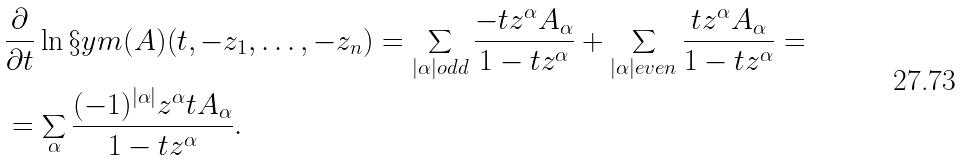<formula> <loc_0><loc_0><loc_500><loc_500>& \frac { \partial } { \partial t } \ln \S y m ( A ) ( t , - z _ { 1 } , \dots , - z _ { n } ) = \sum _ { | \alpha | o d d } \frac { - t z ^ { \alpha } A _ { \alpha } } { 1 - t z ^ { \alpha } } + \sum _ { | \alpha | e v e n } \frac { t z ^ { \alpha } A _ { \alpha } } { 1 - t z ^ { \alpha } } = \\ & = \sum _ { \alpha } \frac { ( - 1 ) ^ { | \alpha | } z ^ { \alpha } t A _ { \alpha } } { 1 - t z ^ { \alpha } } .</formula> 